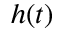<formula> <loc_0><loc_0><loc_500><loc_500>h ( t )</formula> 